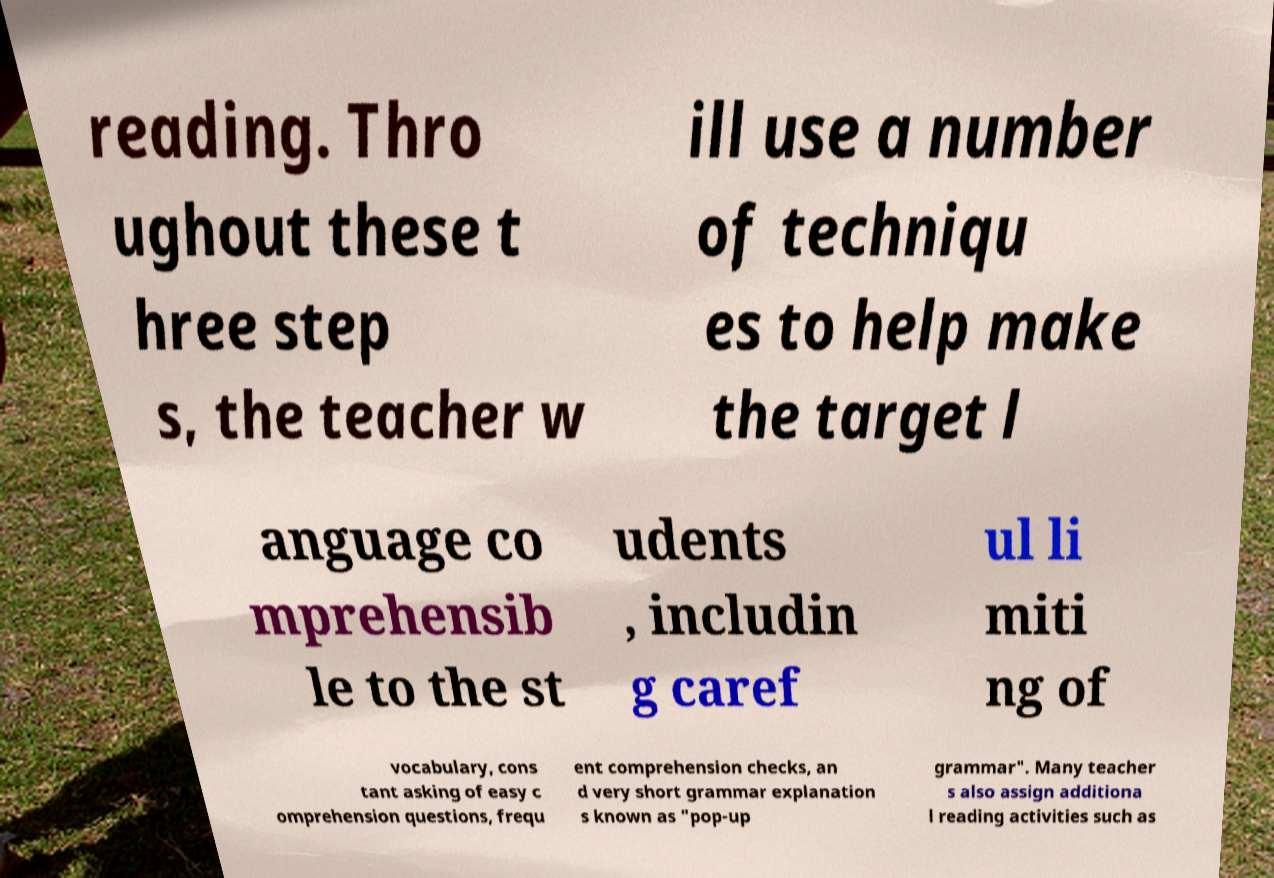For documentation purposes, I need the text within this image transcribed. Could you provide that? reading. Thro ughout these t hree step s, the teacher w ill use a number of techniqu es to help make the target l anguage co mprehensib le to the st udents , includin g caref ul li miti ng of vocabulary, cons tant asking of easy c omprehension questions, frequ ent comprehension checks, an d very short grammar explanation s known as "pop-up grammar". Many teacher s also assign additiona l reading activities such as 